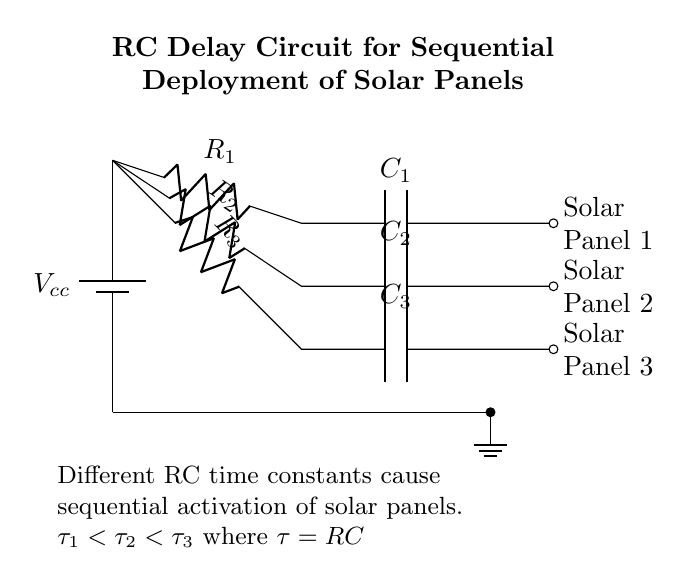What is the power source in the circuit? The circuit diagram shows a battery labeled Vcc, indicating that it is the power source supplying voltage to the RC circuits.
Answer: Vcc How many solar panels are depicted in the circuit? The circuit displays three solar panels, as indicated by the labels for each RC circuit branch. Each branch corresponds to one solar panel.
Answer: Three What are the components of the first RC circuit? The first RC circuit consists of a resistor labeled R1 followed by a capacitor labeled C1. These two components are connected in series.
Answer: R1, C1 How does the time constant compare among the three RC circuits? The time constants are denoted as tau one, tau two, and tau three, which correspond to their respective resistors and capacitors. The relationships indicate that tau one is less than tau two, which is less than tau three, meaning the first RC circuit activates before the others.
Answer: tau one < tau two < tau three What is the purpose of using different RC time constants in this circuit? Different RC time constants ensure that each solar panel is activated sequentially rather than all at once. This allows for better energy management and coordination in deployment during space missions.
Answer: Sequential activation 